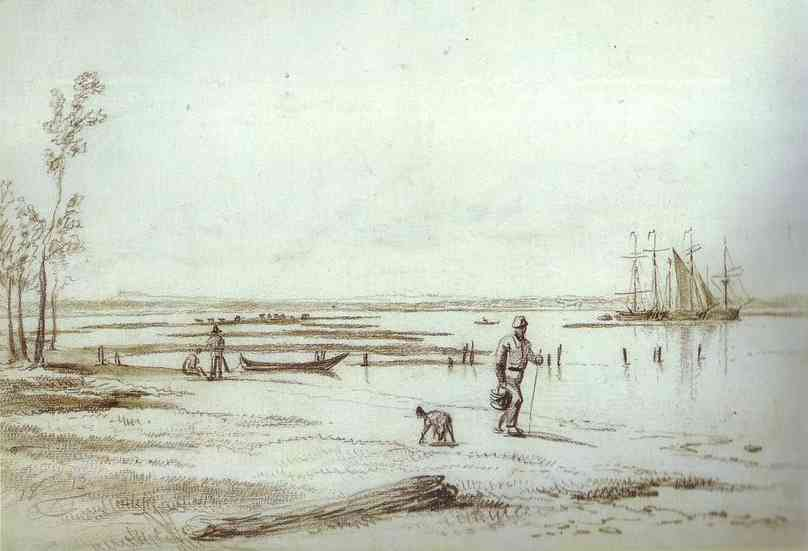What is this photo about? The image captures a serene and picturesque landscape scene, possibly sketched in the early modern period judging by the style and attire of the figure. A man, dressed in period clothing, stands at the shore with his loyal dog, both absorbed in the tranquil setting. The scene includes a softly outlined boat resting at the water's edge and a larger ship in the distance, suggesting this might be a busy river or coastal area used for transport. Trees frame the left side, adding to the composition's balance and inviting viewers to ponder the quiet moments of life before modernity's rush. The artwork not only serves as a calming visual escape but also invites reflection on the passage of time and the enduring beauty of nature's interactions with human and animal life. 